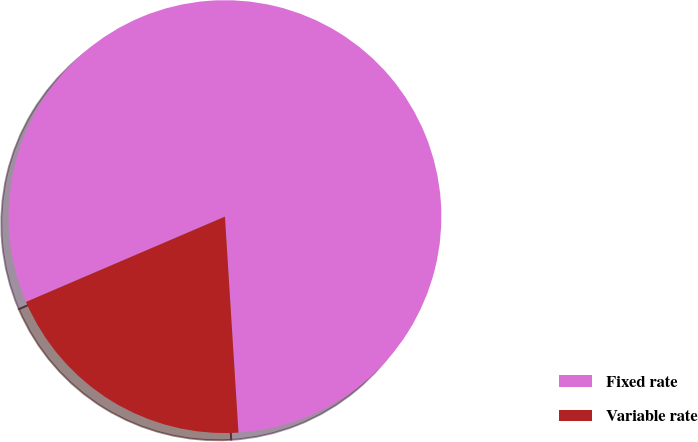<chart> <loc_0><loc_0><loc_500><loc_500><pie_chart><fcel>Fixed rate<fcel>Variable rate<nl><fcel>80.45%<fcel>19.55%<nl></chart> 